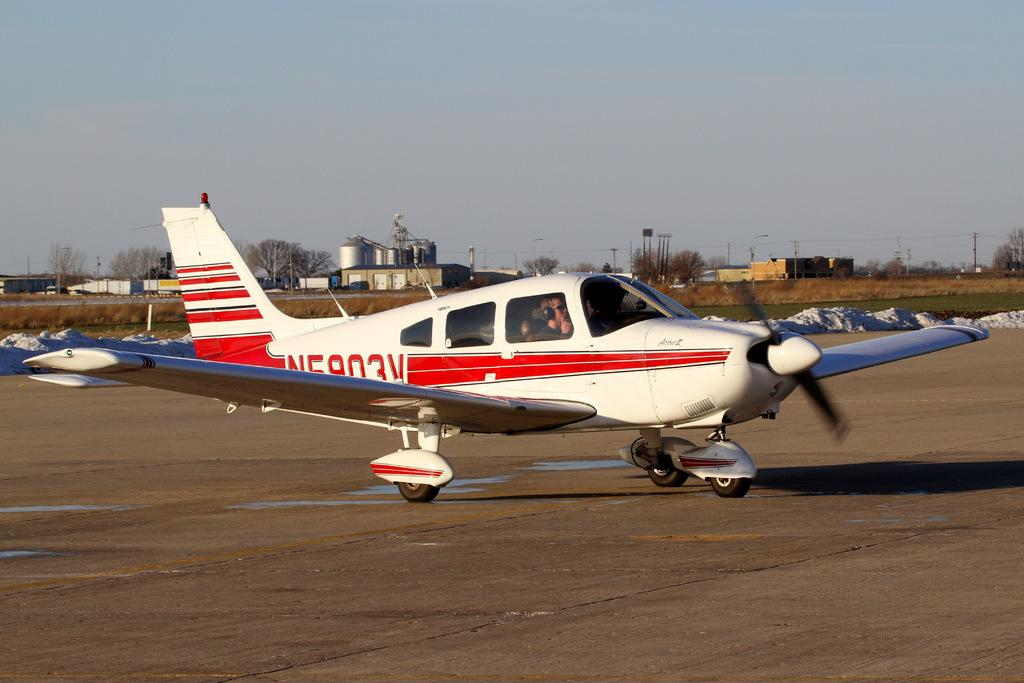<image>
Offer a succinct explanation of the picture presented. a small plane that says n5903v on the side of it 